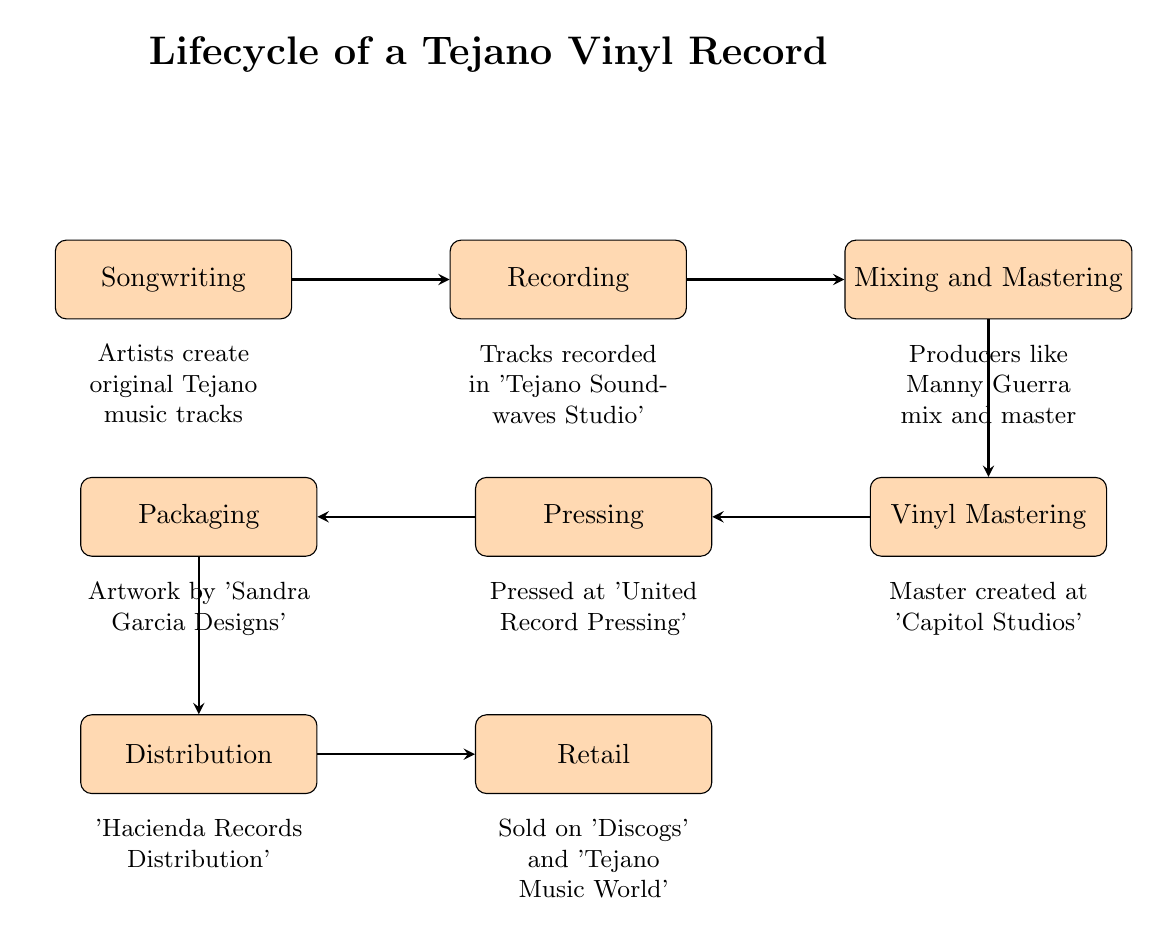What is the first step in the lifecycle of a vinyl record? The first node in the flow chart is 'Songwriting', indicating that songwriting is the initial step in creating a vinyl record.
Answer: Songwriting How many nodes are present in the diagram? By counting each unique step represented within the flow chart, we find a total of 8 distinct nodes.
Answer: 8 What follows after Recording in the process? The edge connecting 'Recording' to 'Mixing and Mastering' shows that those two processes are sequential, with Mixing and Mastering following immediately after Recording.
Answer: Mixing and Mastering Which studio is mentioned for the Recording stage? The description of the 'Recording' node specifies 'Tejano Soundwaves Studio' as the location where tracks are recorded, establishing the direct association.
Answer: Tejano Soundwaves Studio What is the final step before retailing the vinyl records? Looking at the flow, the last step before records reach retail is 'Distribution', which indicates that all previously created records must first be distributed.
Answer: Distribution Which designer's artwork is used in the Packaging step? The node for 'Packaging' specifically mentions 'Sandra Garcia Designs', indicating that this designer is responsible for the artwork used on the packaging of the vinyl records.
Answer: Sandra Garcia Designs In what order does vinyl mastering occur regarding Mixing and Mastering? The flow shows that 'Vinyl Mastering' directly follows 'Mixing and Mastering', indicating that it comes afterward in the lifecycle sequence.
Answer: After What type of records are pressed at the factory mentioned? The edge points from 'Vinyl Mastering' to 'Pressing', and looking at the 'Pressing' node, it specifies that vinyl records are pressed in this stage.
Answer: Vinyl records Who is responsible for distributing the records? The 'Distribution' node clearly indicates 'Hacienda Records Distribution' as the entity in charge of distributing the vinyl records, directly addressing the question.
Answer: Hacienda Records Distribution 